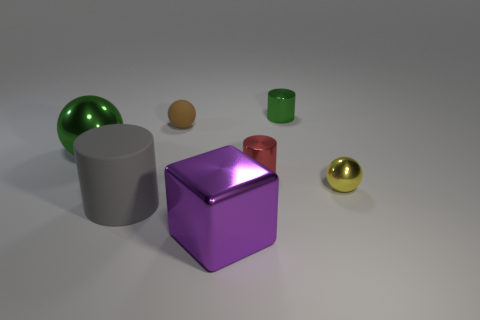How many small things are purple things or matte spheres?
Make the answer very short. 1. Are there any small green objects behind the red cylinder?
Offer a terse response. Yes. Is the number of big matte objects that are left of the tiny yellow shiny thing the same as the number of green objects?
Give a very brief answer. No. The other matte object that is the same shape as the tiny green object is what size?
Make the answer very short. Large. There is a large green metal object; does it have the same shape as the tiny yellow metallic thing in front of the brown rubber ball?
Your response must be concise. Yes. There is a metallic cylinder in front of the large thing that is to the left of the large gray cylinder; how big is it?
Keep it short and to the point. Small. Are there an equal number of tiny metallic cylinders on the left side of the tiny green metallic cylinder and metallic cylinders that are behind the brown thing?
Make the answer very short. Yes. There is another metallic object that is the same shape as the yellow shiny object; what color is it?
Keep it short and to the point. Green. How many things are the same color as the big metallic ball?
Give a very brief answer. 1. Is the shape of the metal object that is behind the brown rubber object the same as  the large gray thing?
Make the answer very short. Yes. 